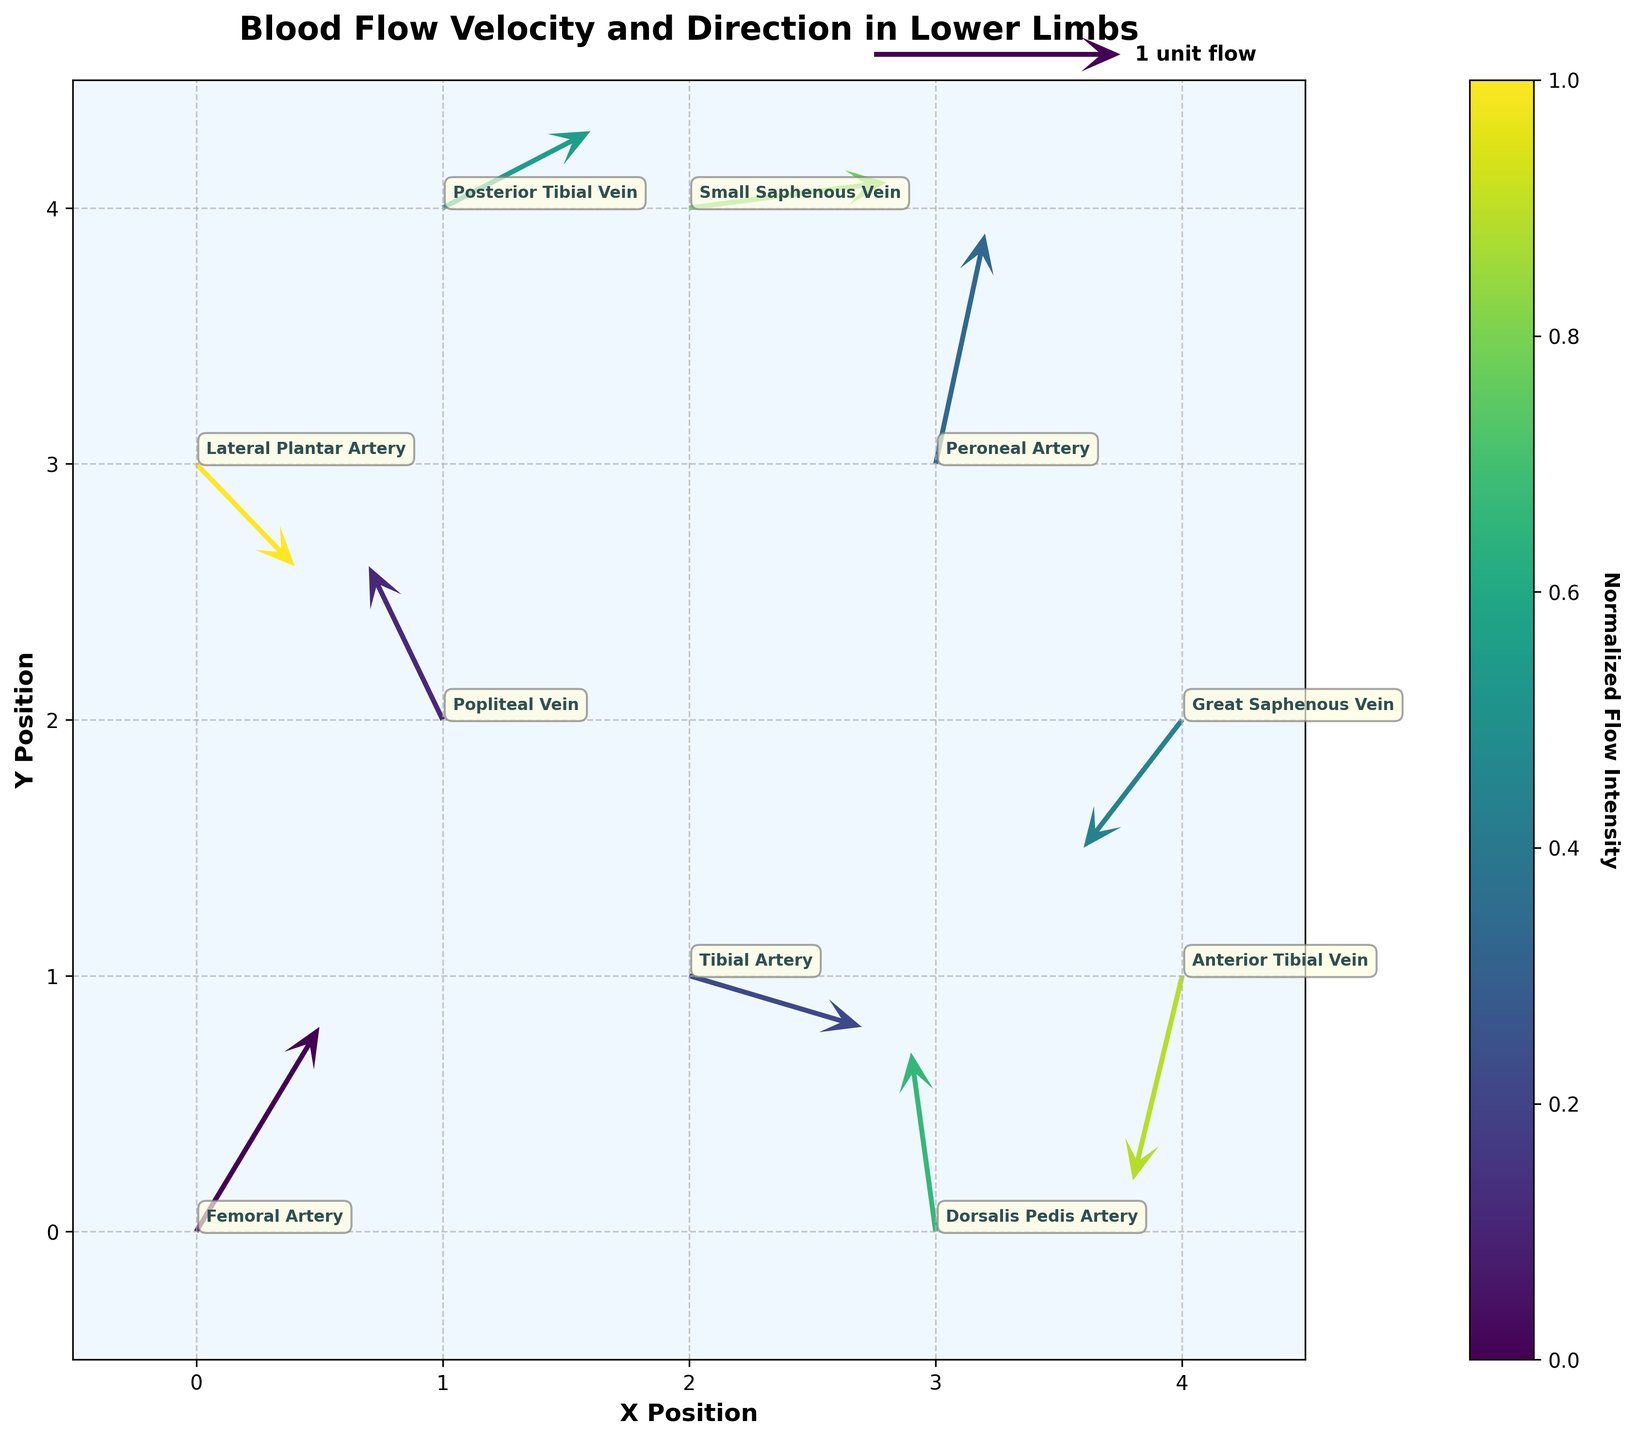What is the title of the figure? The title is written at the top of the figure, and it states the main subject of the plot.
Answer: Blood Flow Velocity and Direction in Lower Limbs How many unique locations are represented in the figure? Each data point is labeled with a unique location, and counting these labels provides the number of unique locations.
Answer: 10 What is the direction of blood flow in the Femoral Artery? The direction of blood flow in the Femoral Artery can be determined by the arrow originating from the corresponding data point. The arrow's direction would indicate vector components (u, v) = (0.5, 0.8).
Answer: Upward-right Which location has the highest positive x-component of velocity? By examining the magnitude of the u-component for each arrow, the data point with the largest positive x-component can be identified. The highest x-component is u = 0.8.
Answer: Small Saphenous Vein Which vein shows negative y-component of velocity? By observing the y-components (v-values) of the velocity vectors and identifying the ones that are negative, and noting the respective labels. The negative y-component in a vein is found in v = -0.8.
Answer: Anterior Tibial Vein Between Popliteal Vein and Posterior Tibial Vein, which one has a greater flow intensity (vector magnitude)? Flow intensity can be calculated using the Pythagorean theorem: sqrt(u^2 + v^2). Popliteal Vein has components (-0.3, 0.6) and Posterior Tibial Vein has (0.6, 0.3).
Answer: Posterior Tibial Vein How many arteries have arrow directions pointing generally upward? Arrows pointing generally upward have positive y-components (v-values). Count the labeled arteries with positive v-values.
Answer: 4 What is the average x-component of the velocity for the Tibial Artery and the Peroneal Artery? Sum the u-components of the Tibial Artery (0.7) and Peroneal Artery (0.2), then divide by 2 for the average. (0.7 + 0.2) / 2 = 0.45.
Answer: 0.45 Which has a more downward direction, Great Saphenous Vein or Anterior Tibial Vein? Downward direction is indicated by a more negative y-component (v). Compare their v-values: Great Saphenous Vein is v = -0.5 and Anterior Tibial Vein is v = -0.8.
Answer: Anterior Tibial Vein What is the flow intensity (vector magnitude) at Dorsalis Pedis Artery? Calculate the vector magnitude with the components (u, v): sqrt((-0.1)^2 + 0.7^2) = sqrt(0.01 + 0.49) = sqrt(0.50) = approximately 0.707.
Answer: 0.707 